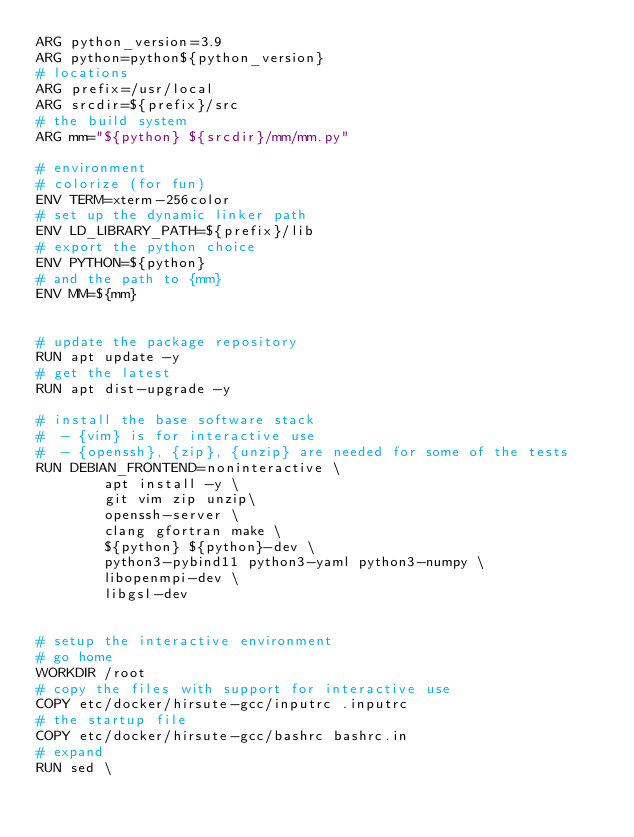<code> <loc_0><loc_0><loc_500><loc_500><_Dockerfile_>ARG python_version=3.9
ARG python=python${python_version}
# locations
ARG prefix=/usr/local
ARG srcdir=${prefix}/src
# the build system
ARG mm="${python} ${srcdir}/mm/mm.py"

# environment
# colorize (for fun)
ENV TERM=xterm-256color
# set up the dynamic linker path
ENV LD_LIBRARY_PATH=${prefix}/lib
# export the python choice
ENV PYTHON=${python}
# and the path to {mm}
ENV MM=${mm}


# update the package repository
RUN apt update -y
# get the latest
RUN apt dist-upgrade -y

# install the base software stack
#  - {vim} is for interactive use
#  - {openssh}, {zip}, {unzip} are needed for some of the tests
RUN DEBIAN_FRONTEND=noninteractive \
        apt install -y \
        git vim zip unzip\
        openssh-server \
        clang gfortran make \
        ${python} ${python}-dev \
        python3-pybind11 python3-yaml python3-numpy \
        libopenmpi-dev \
        libgsl-dev


# setup the interactive environment
# go home
WORKDIR /root
# copy the files with support for interactive use
COPY etc/docker/hirsute-gcc/inputrc .inputrc
# the startup file
COPY etc/docker/hirsute-gcc/bashrc bashrc.in
# expand
RUN sed \</code> 